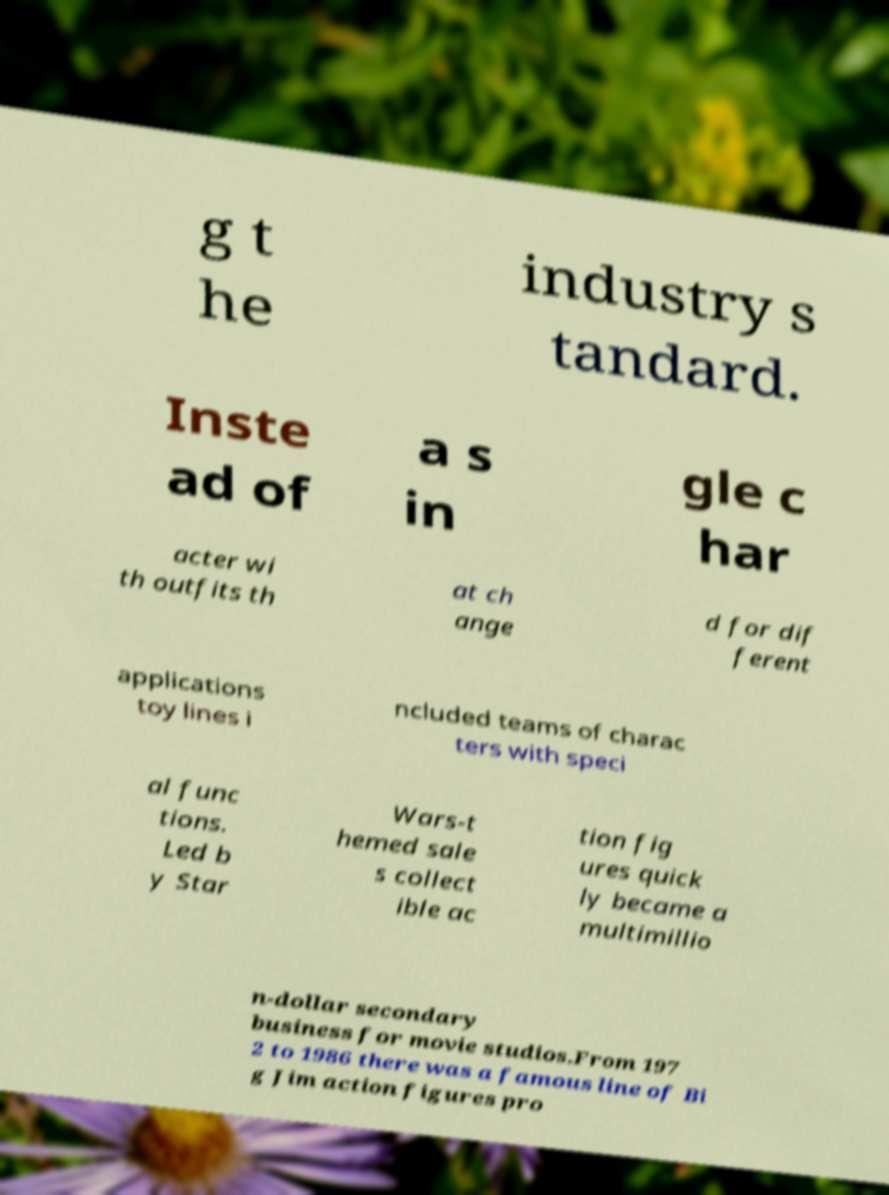Please identify and transcribe the text found in this image. g t he industry s tandard. Inste ad of a s in gle c har acter wi th outfits th at ch ange d for dif ferent applications toy lines i ncluded teams of charac ters with speci al func tions. Led b y Star Wars-t hemed sale s collect ible ac tion fig ures quick ly became a multimillio n-dollar secondary business for movie studios.From 197 2 to 1986 there was a famous line of Bi g Jim action figures pro 